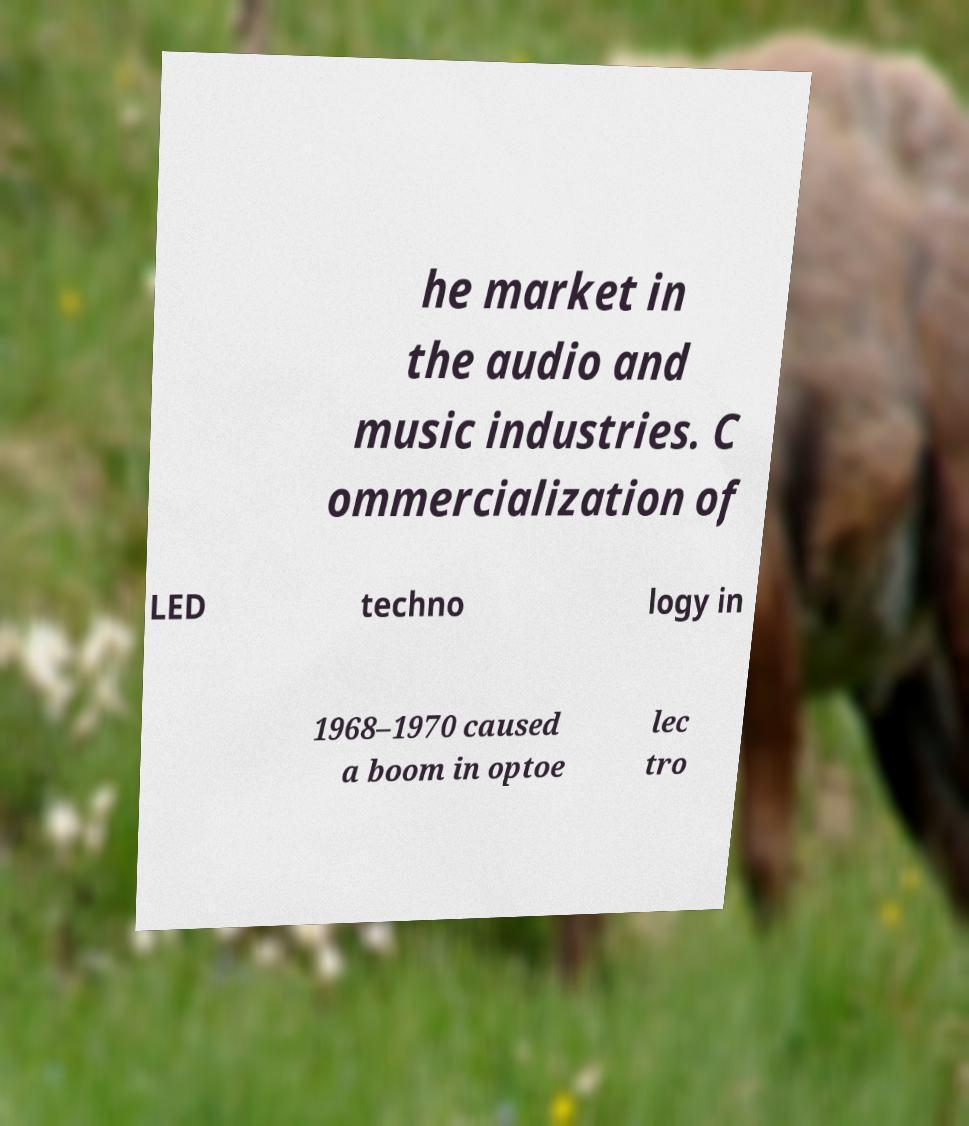There's text embedded in this image that I need extracted. Can you transcribe it verbatim? he market in the audio and music industries. C ommercialization of LED techno logy in 1968–1970 caused a boom in optoe lec tro 